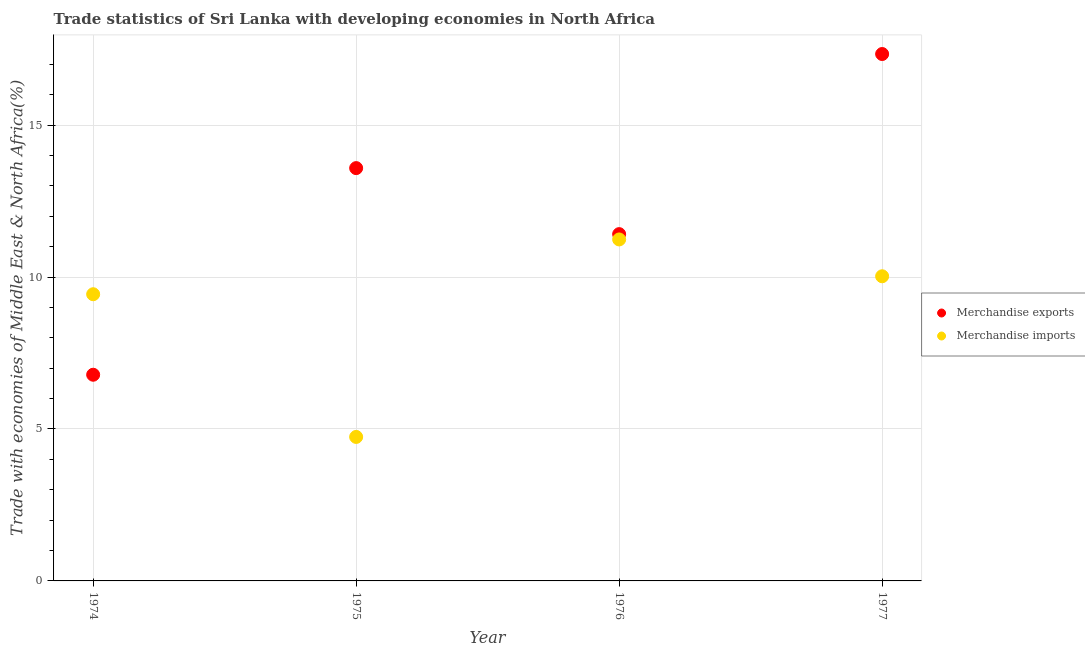How many different coloured dotlines are there?
Your response must be concise. 2. What is the merchandise exports in 1974?
Your answer should be compact. 6.79. Across all years, what is the maximum merchandise exports?
Provide a short and direct response. 17.34. Across all years, what is the minimum merchandise imports?
Give a very brief answer. 4.74. In which year was the merchandise imports minimum?
Give a very brief answer. 1975. What is the total merchandise imports in the graph?
Your response must be concise. 35.44. What is the difference between the merchandise imports in 1976 and that in 1977?
Your answer should be very brief. 1.21. What is the difference between the merchandise exports in 1974 and the merchandise imports in 1977?
Provide a short and direct response. -3.24. What is the average merchandise exports per year?
Your answer should be compact. 12.28. In the year 1976, what is the difference between the merchandise exports and merchandise imports?
Ensure brevity in your answer.  0.18. In how many years, is the merchandise exports greater than 1 %?
Make the answer very short. 4. What is the ratio of the merchandise exports in 1975 to that in 1976?
Your response must be concise. 1.19. Is the merchandise imports in 1974 less than that in 1975?
Provide a short and direct response. No. Is the difference between the merchandise imports in 1974 and 1977 greater than the difference between the merchandise exports in 1974 and 1977?
Give a very brief answer. Yes. What is the difference between the highest and the second highest merchandise exports?
Provide a short and direct response. 3.75. What is the difference between the highest and the lowest merchandise exports?
Your response must be concise. 10.55. Does the merchandise exports monotonically increase over the years?
Your response must be concise. No. How many dotlines are there?
Provide a short and direct response. 2. How many legend labels are there?
Make the answer very short. 2. What is the title of the graph?
Your answer should be very brief. Trade statistics of Sri Lanka with developing economies in North Africa. What is the label or title of the Y-axis?
Your answer should be very brief. Trade with economies of Middle East & North Africa(%). What is the Trade with economies of Middle East & North Africa(%) of Merchandise exports in 1974?
Provide a short and direct response. 6.79. What is the Trade with economies of Middle East & North Africa(%) of Merchandise imports in 1974?
Your response must be concise. 9.43. What is the Trade with economies of Middle East & North Africa(%) of Merchandise exports in 1975?
Your answer should be very brief. 13.59. What is the Trade with economies of Middle East & North Africa(%) in Merchandise imports in 1975?
Offer a terse response. 4.74. What is the Trade with economies of Middle East & North Africa(%) of Merchandise exports in 1976?
Your answer should be very brief. 11.41. What is the Trade with economies of Middle East & North Africa(%) of Merchandise imports in 1976?
Your response must be concise. 11.24. What is the Trade with economies of Middle East & North Africa(%) in Merchandise exports in 1977?
Your response must be concise. 17.34. What is the Trade with economies of Middle East & North Africa(%) of Merchandise imports in 1977?
Offer a terse response. 10.03. Across all years, what is the maximum Trade with economies of Middle East & North Africa(%) in Merchandise exports?
Give a very brief answer. 17.34. Across all years, what is the maximum Trade with economies of Middle East & North Africa(%) of Merchandise imports?
Ensure brevity in your answer.  11.24. Across all years, what is the minimum Trade with economies of Middle East & North Africa(%) in Merchandise exports?
Provide a short and direct response. 6.79. Across all years, what is the minimum Trade with economies of Middle East & North Africa(%) of Merchandise imports?
Provide a succinct answer. 4.74. What is the total Trade with economies of Middle East & North Africa(%) in Merchandise exports in the graph?
Your response must be concise. 49.12. What is the total Trade with economies of Middle East & North Africa(%) in Merchandise imports in the graph?
Keep it short and to the point. 35.44. What is the difference between the Trade with economies of Middle East & North Africa(%) in Merchandise exports in 1974 and that in 1975?
Your response must be concise. -6.8. What is the difference between the Trade with economies of Middle East & North Africa(%) in Merchandise imports in 1974 and that in 1975?
Provide a short and direct response. 4.7. What is the difference between the Trade with economies of Middle East & North Africa(%) in Merchandise exports in 1974 and that in 1976?
Offer a terse response. -4.63. What is the difference between the Trade with economies of Middle East & North Africa(%) of Merchandise imports in 1974 and that in 1976?
Make the answer very short. -1.8. What is the difference between the Trade with economies of Middle East & North Africa(%) of Merchandise exports in 1974 and that in 1977?
Your response must be concise. -10.55. What is the difference between the Trade with economies of Middle East & North Africa(%) of Merchandise imports in 1974 and that in 1977?
Your answer should be very brief. -0.59. What is the difference between the Trade with economies of Middle East & North Africa(%) in Merchandise exports in 1975 and that in 1976?
Offer a very short reply. 2.17. What is the difference between the Trade with economies of Middle East & North Africa(%) of Merchandise imports in 1975 and that in 1976?
Give a very brief answer. -6.5. What is the difference between the Trade with economies of Middle East & North Africa(%) in Merchandise exports in 1975 and that in 1977?
Provide a succinct answer. -3.75. What is the difference between the Trade with economies of Middle East & North Africa(%) of Merchandise imports in 1975 and that in 1977?
Your answer should be compact. -5.29. What is the difference between the Trade with economies of Middle East & North Africa(%) of Merchandise exports in 1976 and that in 1977?
Give a very brief answer. -5.93. What is the difference between the Trade with economies of Middle East & North Africa(%) in Merchandise imports in 1976 and that in 1977?
Your response must be concise. 1.21. What is the difference between the Trade with economies of Middle East & North Africa(%) in Merchandise exports in 1974 and the Trade with economies of Middle East & North Africa(%) in Merchandise imports in 1975?
Ensure brevity in your answer.  2.05. What is the difference between the Trade with economies of Middle East & North Africa(%) in Merchandise exports in 1974 and the Trade with economies of Middle East & North Africa(%) in Merchandise imports in 1976?
Your answer should be very brief. -4.45. What is the difference between the Trade with economies of Middle East & North Africa(%) in Merchandise exports in 1974 and the Trade with economies of Middle East & North Africa(%) in Merchandise imports in 1977?
Your answer should be very brief. -3.24. What is the difference between the Trade with economies of Middle East & North Africa(%) in Merchandise exports in 1975 and the Trade with economies of Middle East & North Africa(%) in Merchandise imports in 1976?
Keep it short and to the point. 2.35. What is the difference between the Trade with economies of Middle East & North Africa(%) of Merchandise exports in 1975 and the Trade with economies of Middle East & North Africa(%) of Merchandise imports in 1977?
Give a very brief answer. 3.56. What is the difference between the Trade with economies of Middle East & North Africa(%) in Merchandise exports in 1976 and the Trade with economies of Middle East & North Africa(%) in Merchandise imports in 1977?
Offer a very short reply. 1.39. What is the average Trade with economies of Middle East & North Africa(%) of Merchandise exports per year?
Your answer should be very brief. 12.28. What is the average Trade with economies of Middle East & North Africa(%) of Merchandise imports per year?
Your answer should be very brief. 8.86. In the year 1974, what is the difference between the Trade with economies of Middle East & North Africa(%) of Merchandise exports and Trade with economies of Middle East & North Africa(%) of Merchandise imports?
Give a very brief answer. -2.65. In the year 1975, what is the difference between the Trade with economies of Middle East & North Africa(%) of Merchandise exports and Trade with economies of Middle East & North Africa(%) of Merchandise imports?
Offer a terse response. 8.85. In the year 1976, what is the difference between the Trade with economies of Middle East & North Africa(%) of Merchandise exports and Trade with economies of Middle East & North Africa(%) of Merchandise imports?
Provide a short and direct response. 0.17. In the year 1977, what is the difference between the Trade with economies of Middle East & North Africa(%) of Merchandise exports and Trade with economies of Middle East & North Africa(%) of Merchandise imports?
Your answer should be very brief. 7.31. What is the ratio of the Trade with economies of Middle East & North Africa(%) in Merchandise exports in 1974 to that in 1975?
Provide a short and direct response. 0.5. What is the ratio of the Trade with economies of Middle East & North Africa(%) of Merchandise imports in 1974 to that in 1975?
Make the answer very short. 1.99. What is the ratio of the Trade with economies of Middle East & North Africa(%) of Merchandise exports in 1974 to that in 1976?
Your answer should be very brief. 0.59. What is the ratio of the Trade with economies of Middle East & North Africa(%) of Merchandise imports in 1974 to that in 1976?
Make the answer very short. 0.84. What is the ratio of the Trade with economies of Middle East & North Africa(%) in Merchandise exports in 1974 to that in 1977?
Make the answer very short. 0.39. What is the ratio of the Trade with economies of Middle East & North Africa(%) of Merchandise imports in 1974 to that in 1977?
Provide a short and direct response. 0.94. What is the ratio of the Trade with economies of Middle East & North Africa(%) of Merchandise exports in 1975 to that in 1976?
Provide a succinct answer. 1.19. What is the ratio of the Trade with economies of Middle East & North Africa(%) in Merchandise imports in 1975 to that in 1976?
Your answer should be very brief. 0.42. What is the ratio of the Trade with economies of Middle East & North Africa(%) in Merchandise exports in 1975 to that in 1977?
Make the answer very short. 0.78. What is the ratio of the Trade with economies of Middle East & North Africa(%) in Merchandise imports in 1975 to that in 1977?
Ensure brevity in your answer.  0.47. What is the ratio of the Trade with economies of Middle East & North Africa(%) in Merchandise exports in 1976 to that in 1977?
Provide a succinct answer. 0.66. What is the ratio of the Trade with economies of Middle East & North Africa(%) of Merchandise imports in 1976 to that in 1977?
Your answer should be compact. 1.12. What is the difference between the highest and the second highest Trade with economies of Middle East & North Africa(%) of Merchandise exports?
Make the answer very short. 3.75. What is the difference between the highest and the second highest Trade with economies of Middle East & North Africa(%) of Merchandise imports?
Ensure brevity in your answer.  1.21. What is the difference between the highest and the lowest Trade with economies of Middle East & North Africa(%) of Merchandise exports?
Your answer should be compact. 10.55. What is the difference between the highest and the lowest Trade with economies of Middle East & North Africa(%) of Merchandise imports?
Your answer should be very brief. 6.5. 